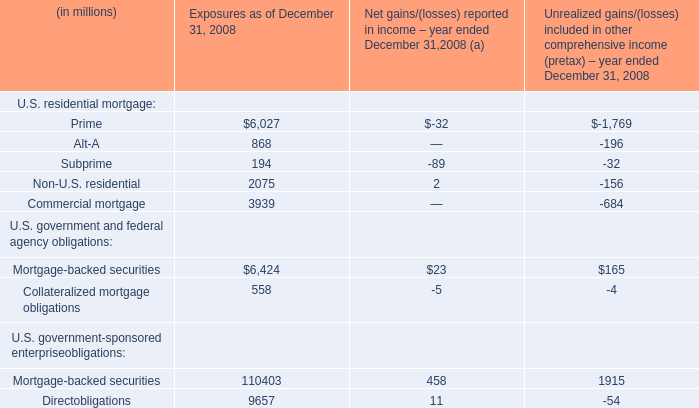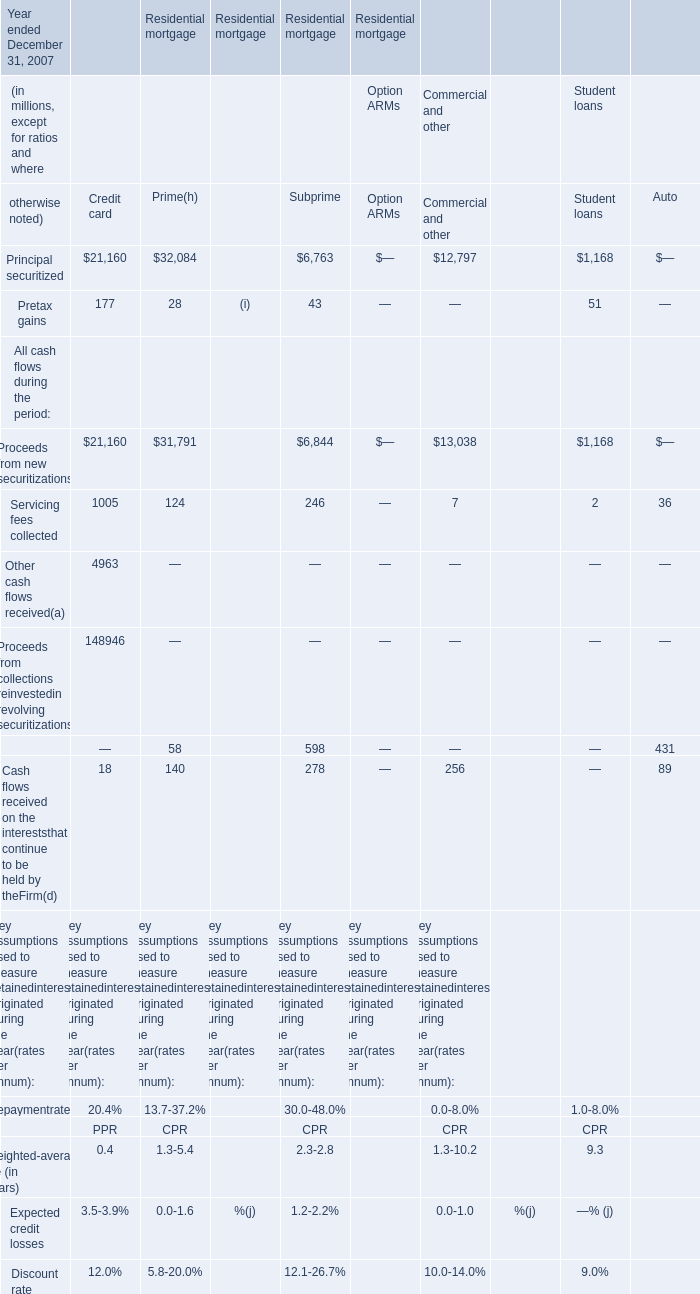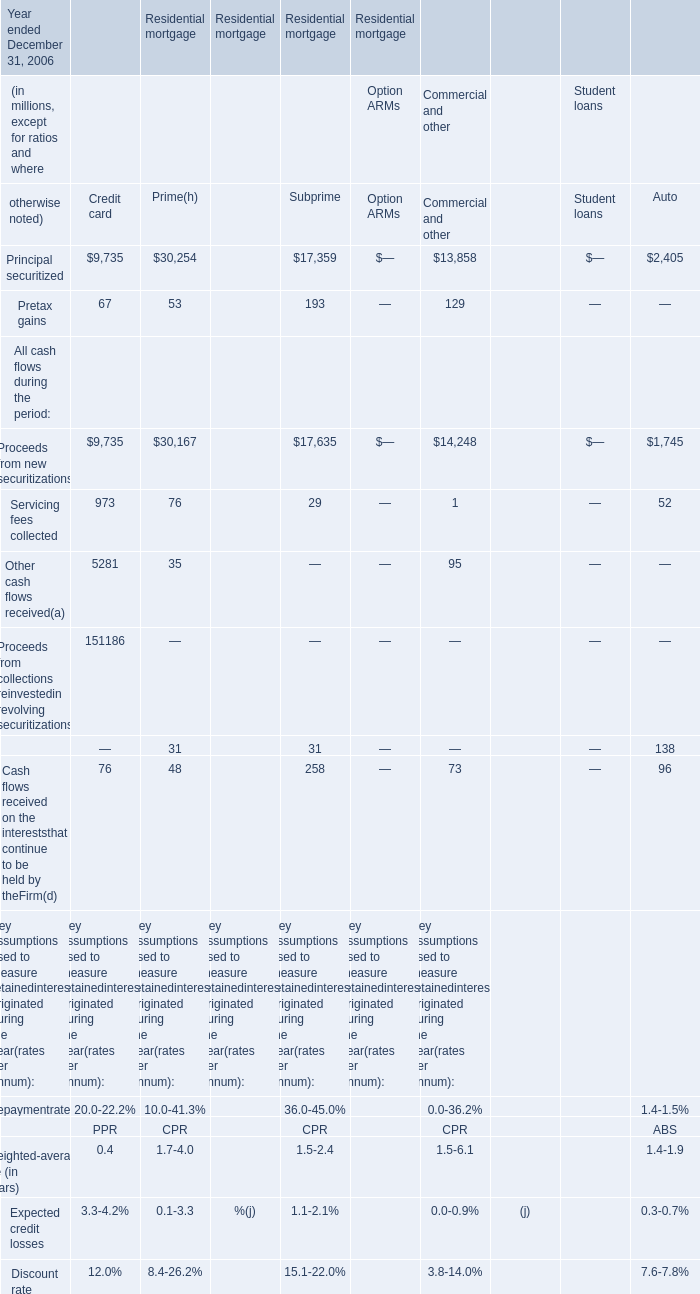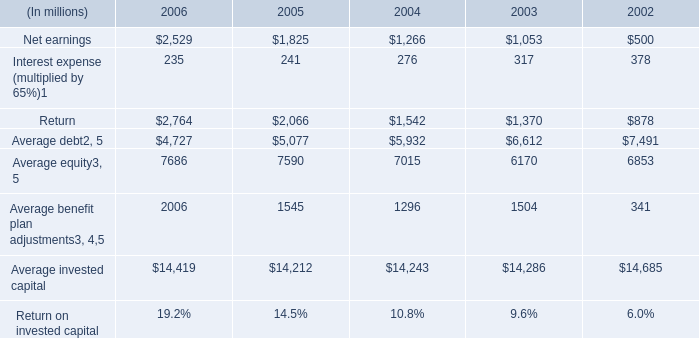What's the sum of Principal securitized of Residential mortgage Credit card, Average benefit plan adjustments of 2004, and Principal securitized of Residential mortgage Student loans ? 
Computations: ((21160.0 + 1296.0) + 1168.0)
Answer: 23624.0. 